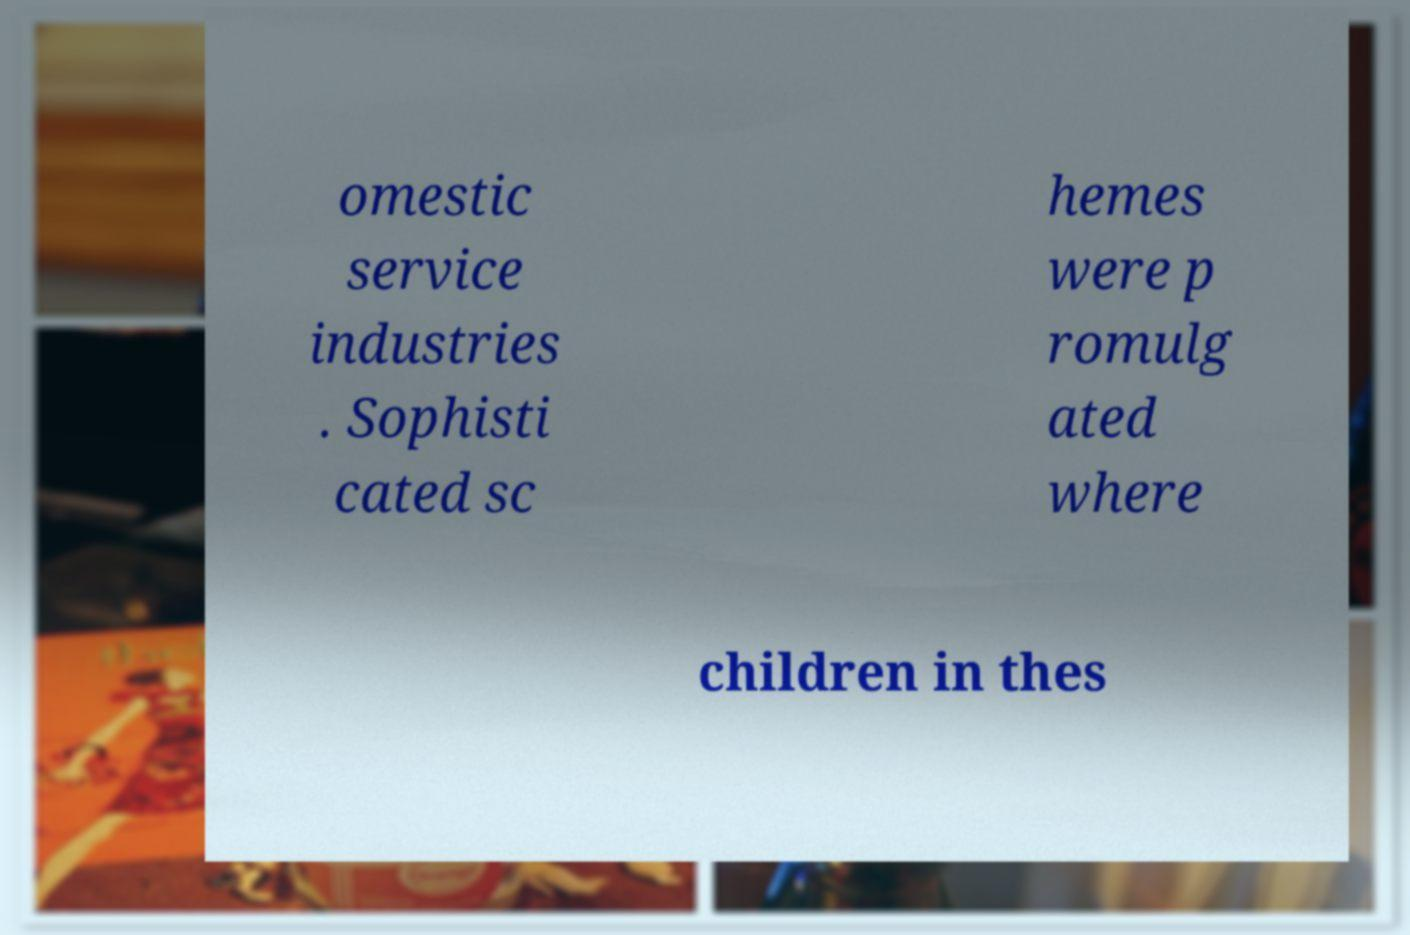Could you extract and type out the text from this image? omestic service industries . Sophisti cated sc hemes were p romulg ated where children in thes 